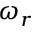Convert formula to latex. <formula><loc_0><loc_0><loc_500><loc_500>\omega _ { r }</formula> 